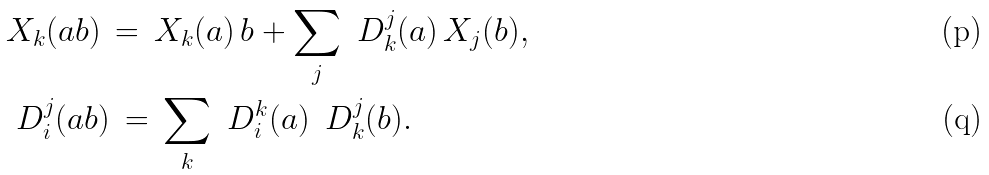<formula> <loc_0><loc_0><loc_500><loc_500>& X _ { k } ( a b ) \, = \, X _ { k } ( a ) \, b + \sum _ { j } \ D ^ { j } _ { k } ( a ) \, X _ { j } ( b ) , \\ & \ D _ { i } ^ { j } ( a b ) \, = \, \sum _ { k } \ D _ { i } ^ { k } ( a ) \, \ D _ { k } ^ { j } ( b ) .</formula> 